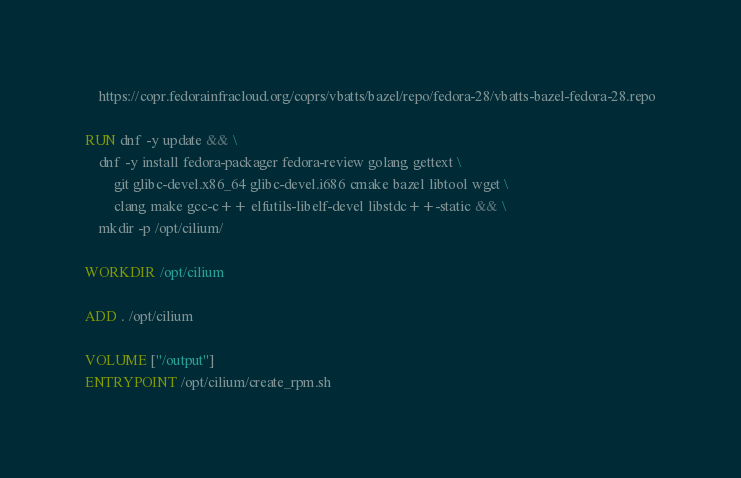<code> <loc_0><loc_0><loc_500><loc_500><_Dockerfile_>	https://copr.fedorainfracloud.org/coprs/vbatts/bazel/repo/fedora-28/vbatts-bazel-fedora-28.repo

RUN dnf -y update && \
	dnf -y install fedora-packager fedora-review golang gettext \
		git glibc-devel.x86_64 glibc-devel.i686 cmake bazel libtool wget \
		clang make gcc-c++ elfutils-libelf-devel libstdc++-static && \
    mkdir -p /opt/cilium/

WORKDIR /opt/cilium

ADD . /opt/cilium

VOLUME ["/output"]
ENTRYPOINT /opt/cilium/create_rpm.sh
</code> 